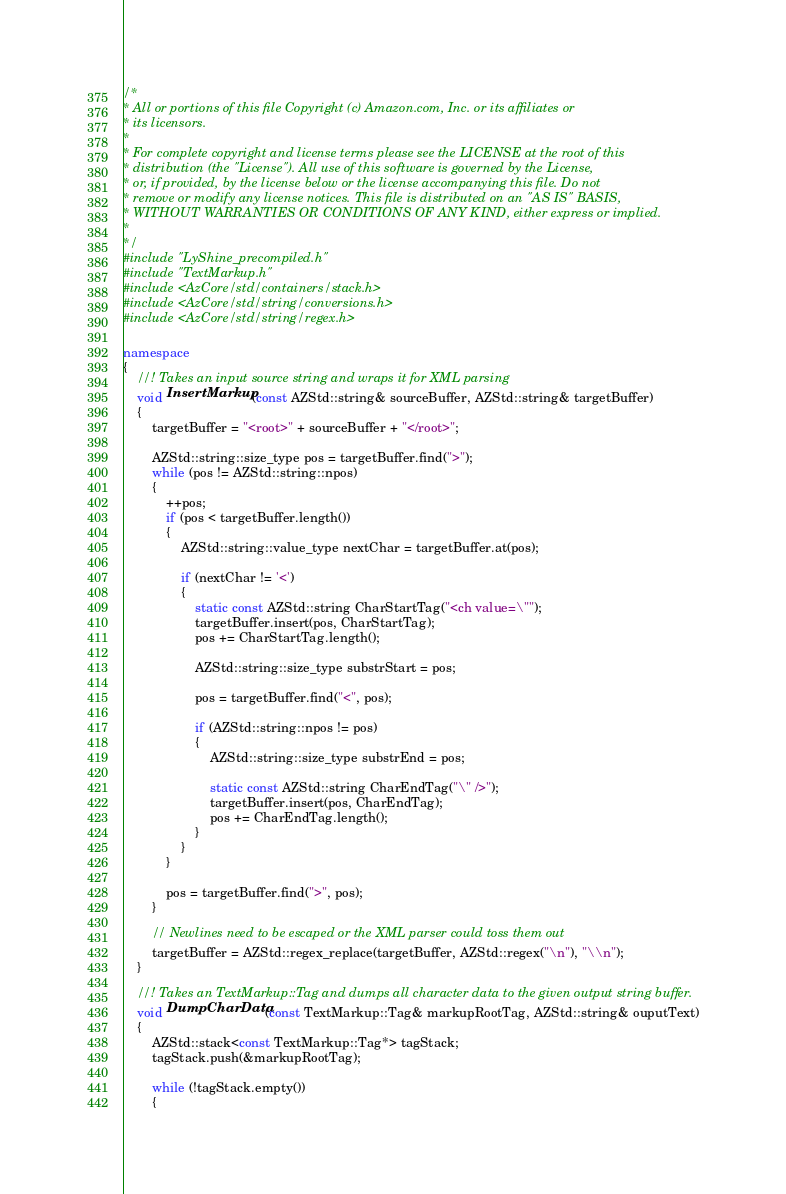Convert code to text. <code><loc_0><loc_0><loc_500><loc_500><_C++_>/*
* All or portions of this file Copyright (c) Amazon.com, Inc. or its affiliates or
* its licensors.
*
* For complete copyright and license terms please see the LICENSE at the root of this
* distribution (the "License"). All use of this software is governed by the License,
* or, if provided, by the license below or the license accompanying this file. Do not
* remove or modify any license notices. This file is distributed on an "AS IS" BASIS,
* WITHOUT WARRANTIES OR CONDITIONS OF ANY KIND, either express or implied.
*
*/
#include "LyShine_precompiled.h"
#include "TextMarkup.h"
#include <AzCore/std/containers/stack.h>
#include <AzCore/std/string/conversions.h>
#include <AzCore/std/string/regex.h>

namespace
{
    //! Takes an input source string and wraps it for XML parsing
    void InsertMarkup(const AZStd::string& sourceBuffer, AZStd::string& targetBuffer)
    {
        targetBuffer = "<root>" + sourceBuffer + "</root>";

        AZStd::string::size_type pos = targetBuffer.find(">");
        while (pos != AZStd::string::npos)
        {
            ++pos;
            if (pos < targetBuffer.length())
            {
                AZStd::string::value_type nextChar = targetBuffer.at(pos);

                if (nextChar != '<')
                {
                    static const AZStd::string CharStartTag("<ch value=\"");
                    targetBuffer.insert(pos, CharStartTag);
                    pos += CharStartTag.length();

                    AZStd::string::size_type substrStart = pos;

                    pos = targetBuffer.find("<", pos);

                    if (AZStd::string::npos != pos)
                    {
                        AZStd::string::size_type substrEnd = pos;

                        static const AZStd::string CharEndTag("\" />");
                        targetBuffer.insert(pos, CharEndTag);
                        pos += CharEndTag.length();
                    }
                }
            }

            pos = targetBuffer.find(">", pos);
        }

        // Newlines need to be escaped or the XML parser could toss them out
        targetBuffer = AZStd::regex_replace(targetBuffer, AZStd::regex("\n"), "\\n");
    }

    //! Takes an TextMarkup::Tag and dumps all character data to the given output string buffer.
    void DumpCharData(const TextMarkup::Tag& markupRootTag, AZStd::string& ouputText)
    {
        AZStd::stack<const TextMarkup::Tag*> tagStack;
        tagStack.push(&markupRootTag);

        while (!tagStack.empty())
        {</code> 